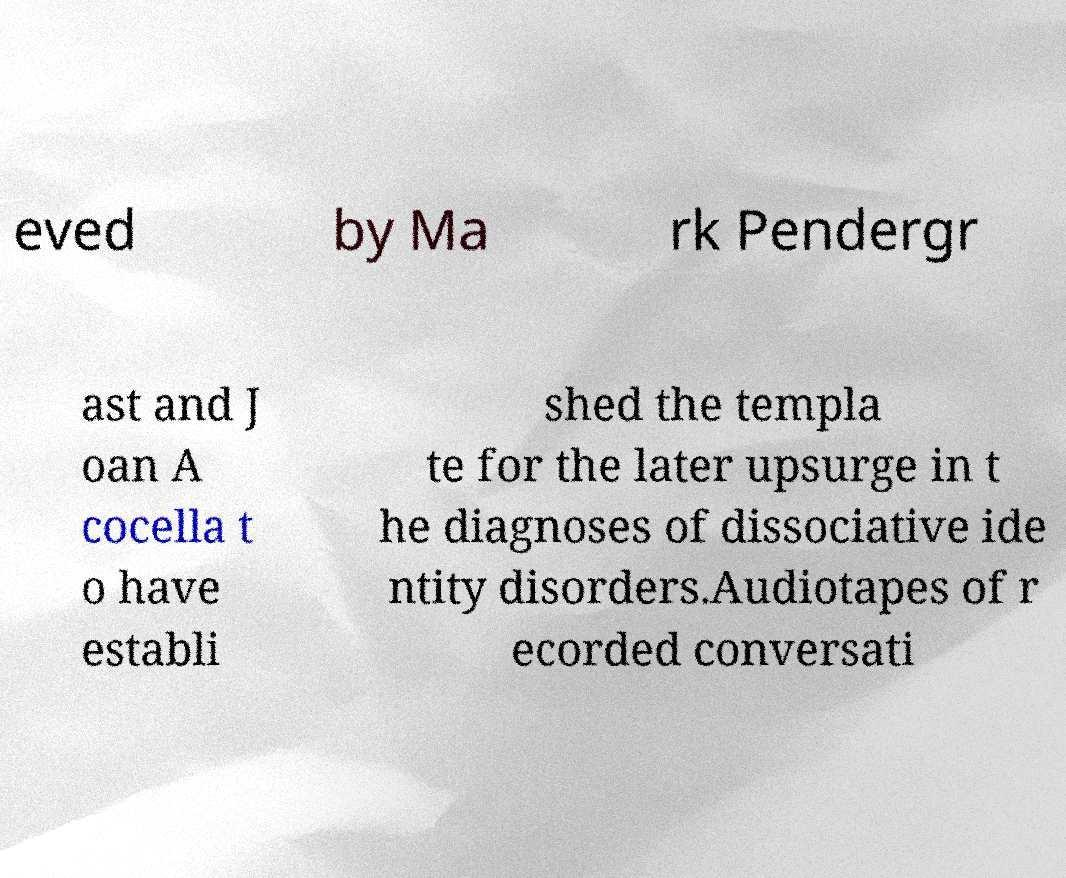Could you extract and type out the text from this image? eved by Ma rk Pendergr ast and J oan A cocella t o have establi shed the templa te for the later upsurge in t he diagnoses of dissociative ide ntity disorders.Audiotapes of r ecorded conversati 